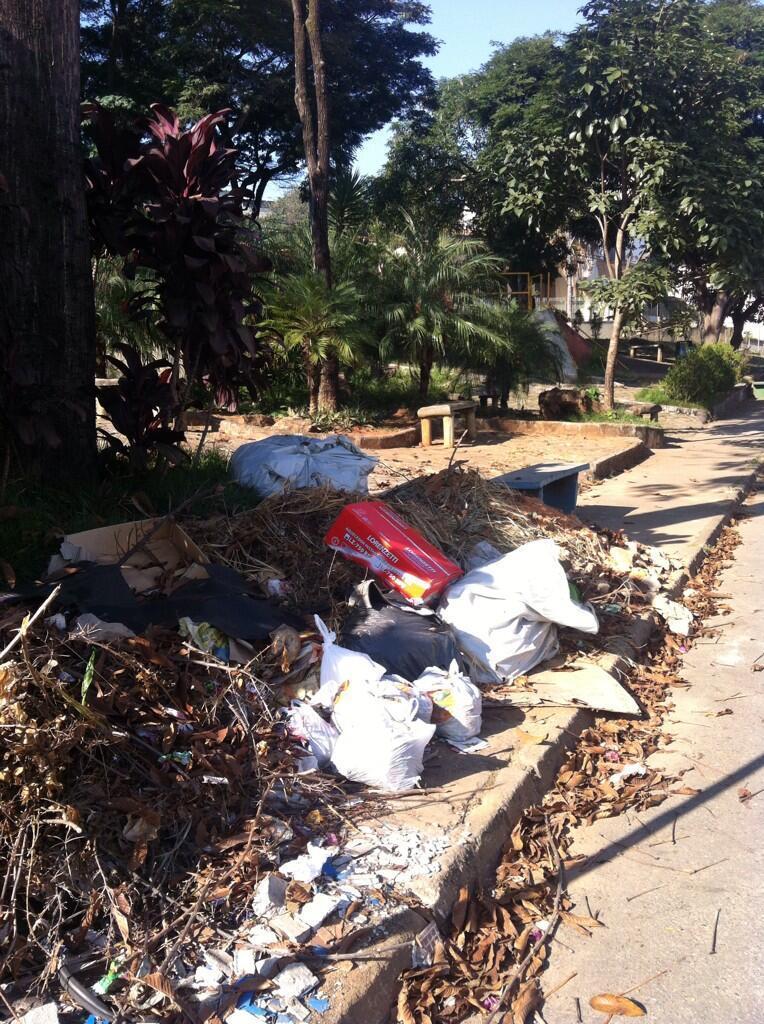How would you summarize this image in a sentence or two? In this image I can see there is a road. Beside the road there are leaves, Covers and box. And above them there are trees and a bench. And at the top there is a sky. 